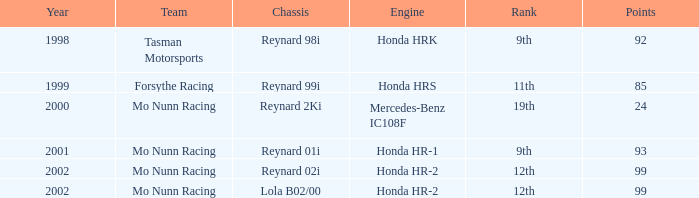Would you mind parsing the complete table? {'header': ['Year', 'Team', 'Chassis', 'Engine', 'Rank', 'Points'], 'rows': [['1998', 'Tasman Motorsports', 'Reynard 98i', 'Honda HRK', '9th', '92'], ['1999', 'Forsythe Racing', 'Reynard 99i', 'Honda HRS', '11th', '85'], ['2000', 'Mo Nunn Racing', 'Reynard 2Ki', 'Mercedes-Benz IC108F', '19th', '24'], ['2001', 'Mo Nunn Racing', 'Reynard 01i', 'Honda HR-1', '9th', '93'], ['2002', 'Mo Nunn Racing', 'Reynard 02i', 'Honda HR-2', '12th', '99'], ['2002', 'Mo Nunn Racing', 'Lola B02/00', 'Honda HR-2', '12th', '99']]} What is the rank of the reynard 2ki chassis before 2002? 19th. 